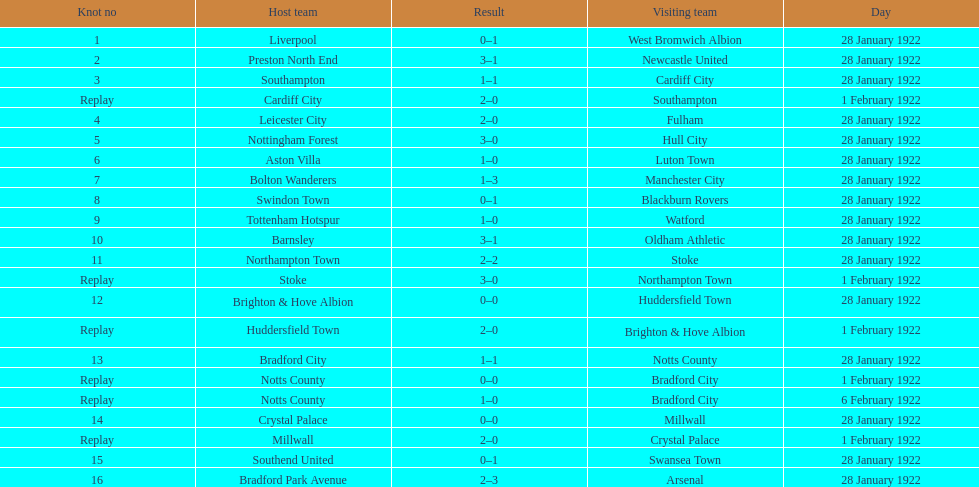What home team had the same score as aston villa on january 28th, 1922? Tottenham Hotspur. 